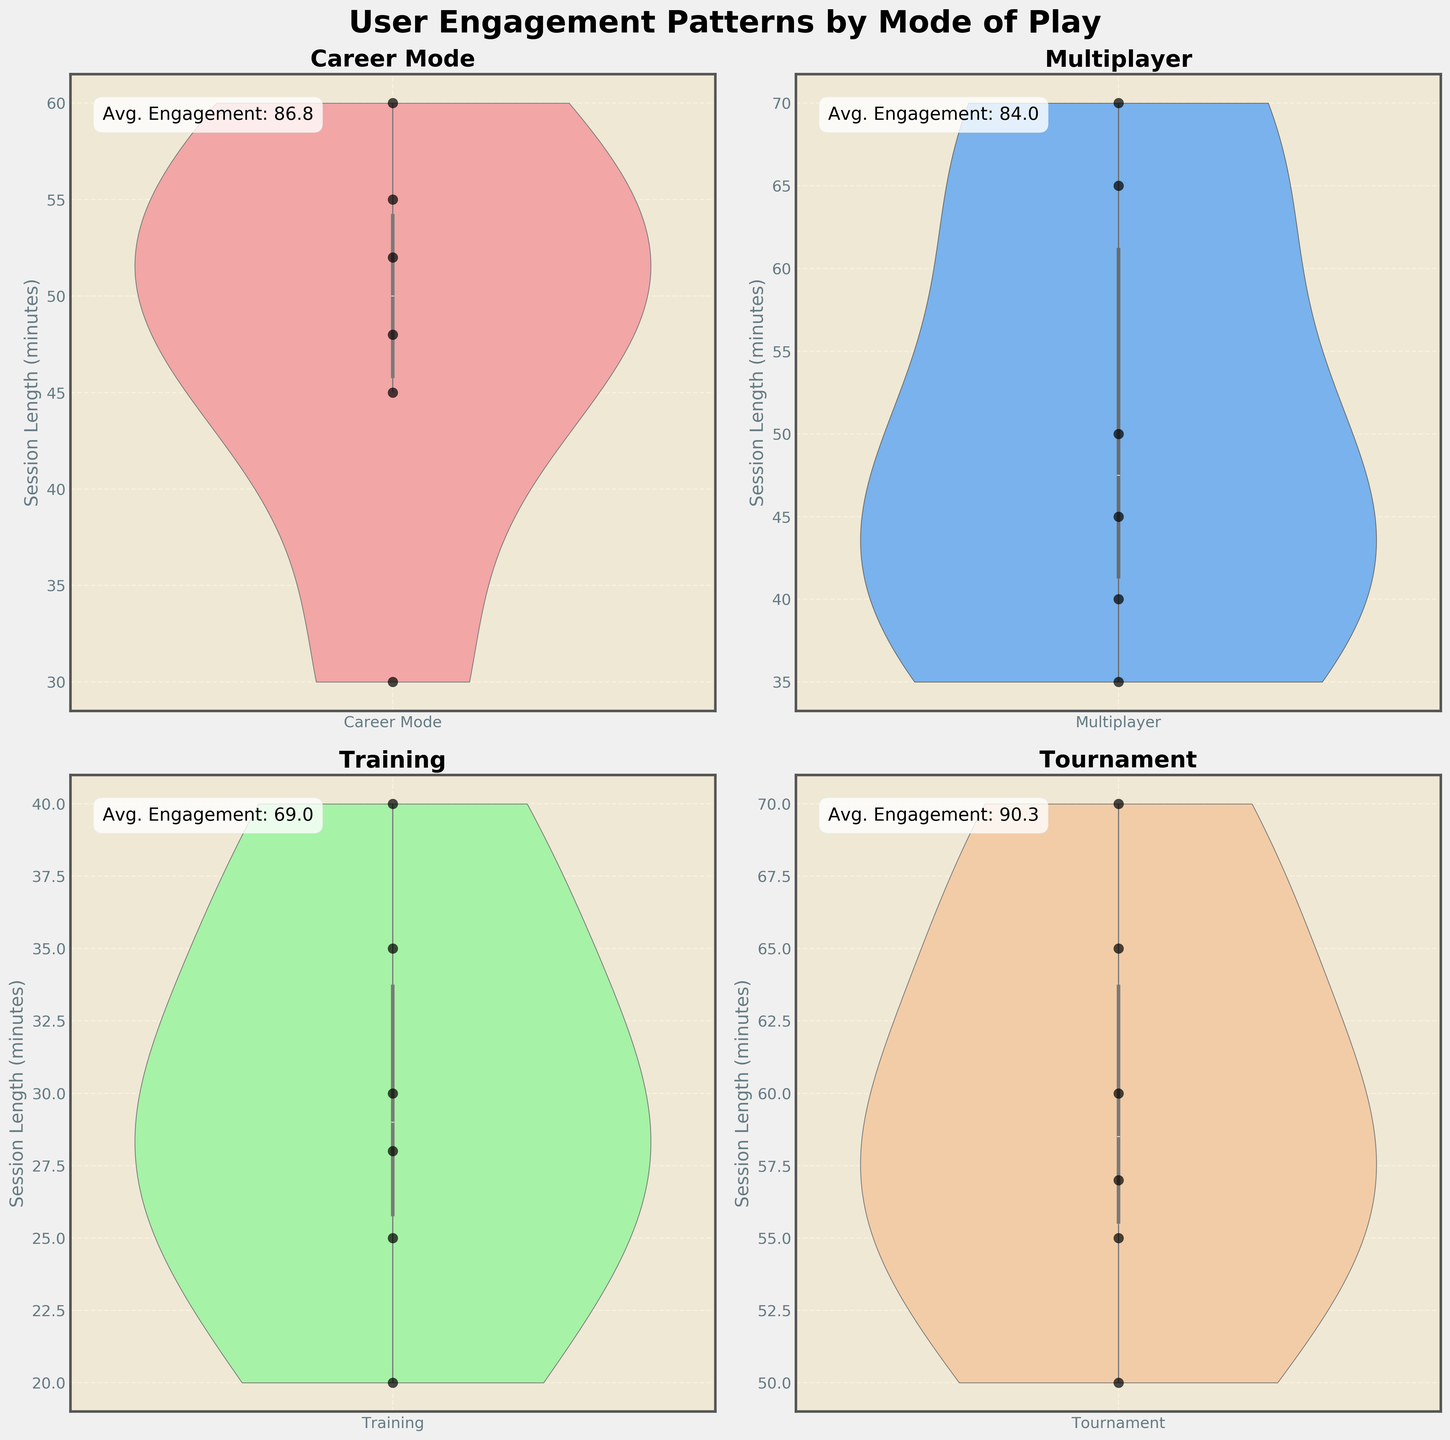What is the title of the plot? The title is displayed at the top of the figure in a large, bold font.
Answer: User Engagement Patterns by Mode of Play Which mode of play shows the highest average engagement score? Each subplot has an average engagement score annotated within the graph. Look for the highest average score among the modes.
Answer: Tournament How many modes of play are presented in the plot? There are four subplots, each representing a different mode of play. Count these subplots.
Answer: 4 Which mode has the widest distribution of session lengths? Look for the mode where the violin plot is the widest, indicating the highest variability.
Answer: Multiplayer What's the average engagement score for the Career Mode? Refer to the annotation within the 'Career Mode' subplot.
Answer: 86.8 Among all modes, which has the shortest session length recorded? Identify the lowest point in all the subplots combined.
Answer: Training Compare the average session lengths between Multiplayer and Training modes. Which one is longer? Look at the position and spread of the session length values in both 'Multiplayer' and 'Training' subplots and compare their average positions.
Answer: Multiplayer What can you infer about the session lengths in Tournament mode compared to the other modes? Tournament mode seems to have longer session lengths compared to other modes, as indicated by the position and spread of the violin plot and swarm points.
Answer: Longer In the Tournament mode subplot, is the highest engagement score higher than 90? Check the engagement score plot annotations and swarm plot points for the Tournament subplot.
Answer: Yes Which mode has the smallest range of session lengths? Identify the mode with the narrowest violin plot, indicating the smallest spread.
Answer: Training 